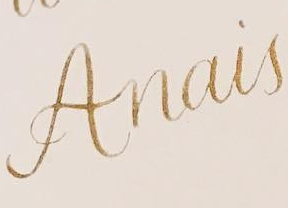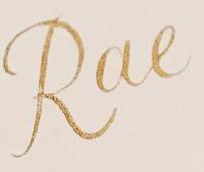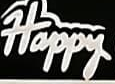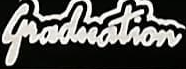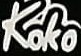Identify the words shown in these images in order, separated by a semicolon. Anais; Rae; Happy; Graduation; Koko 